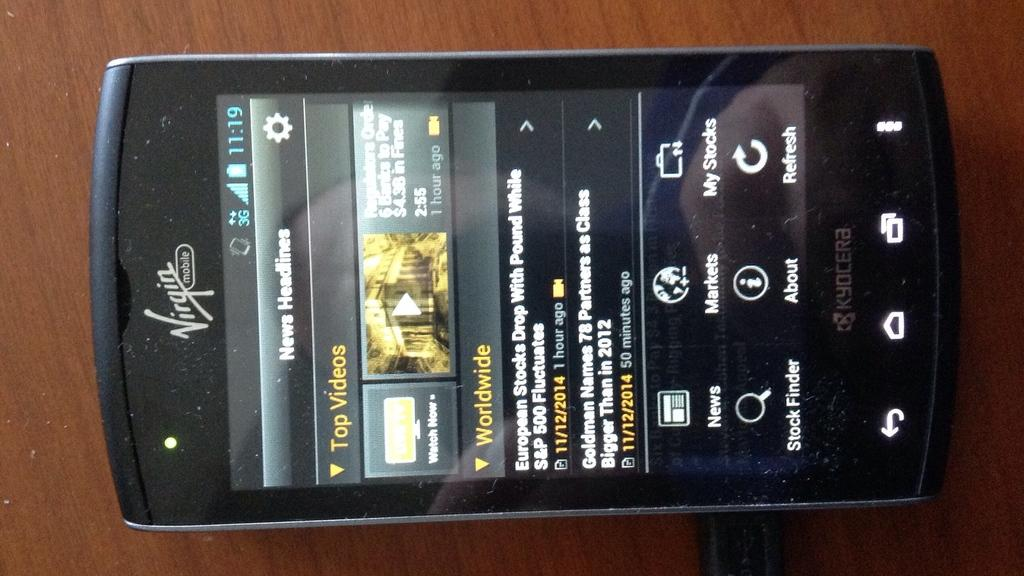<image>
Provide a brief description of the given image. Virgin mobile cellphone that is showing worldwide videos 